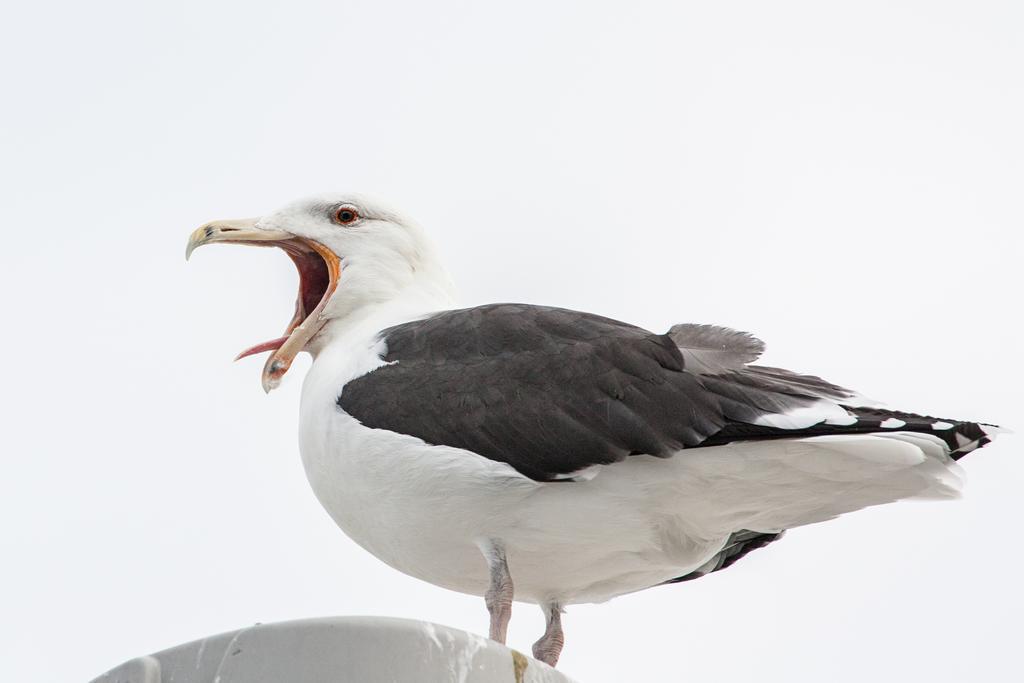In one or two sentences, can you explain what this image depicts? In this image, we can see a black and white bird mouth was open. At the bottom, we can see a white object. Background there is a sky. 